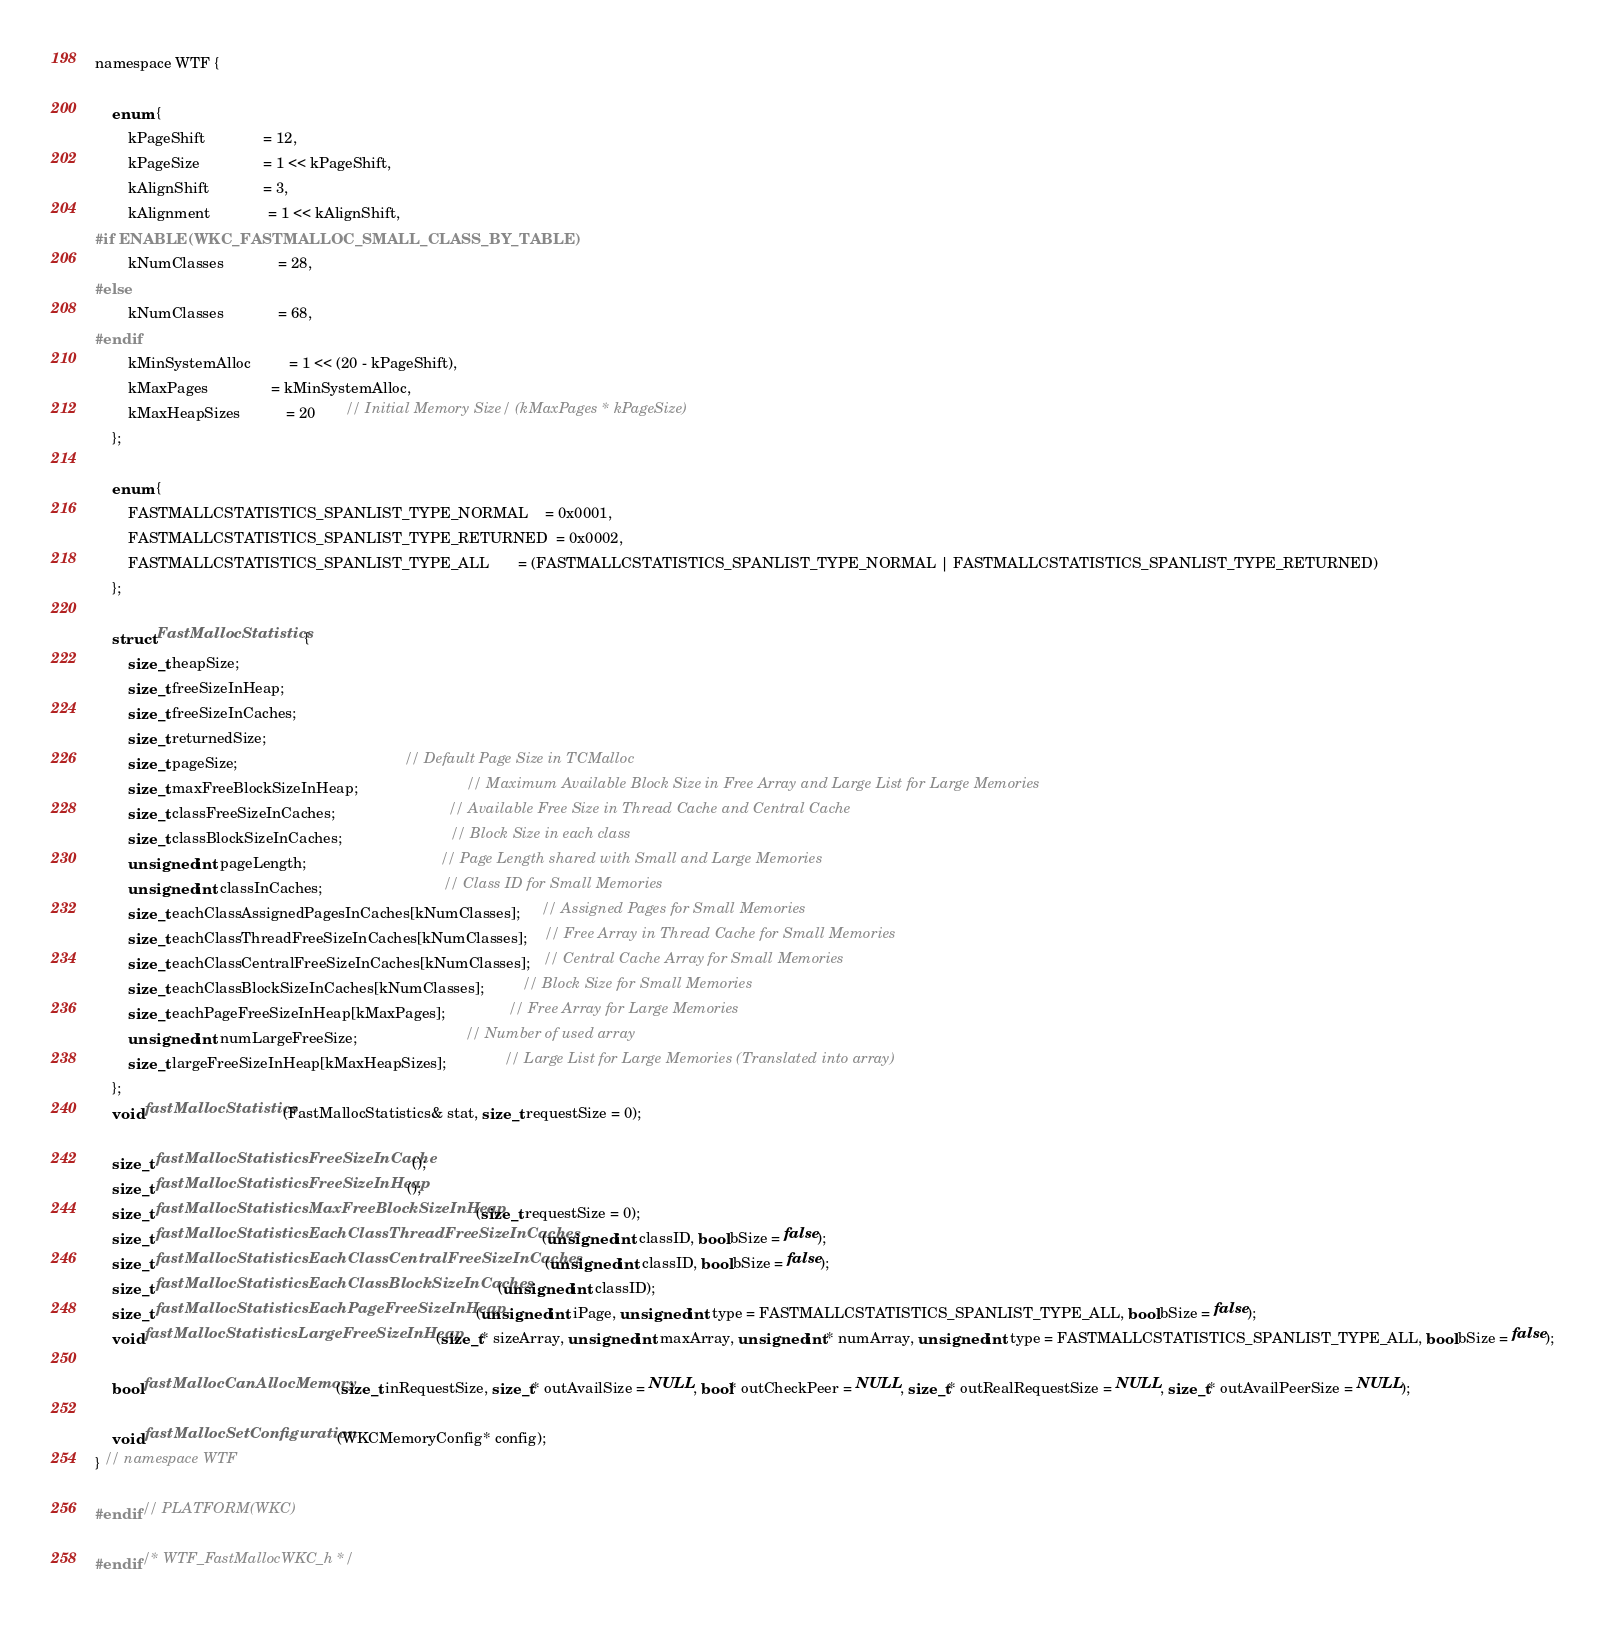Convert code to text. <code><loc_0><loc_0><loc_500><loc_500><_C_>
namespace WTF {

    enum {
        kPageShift              = 12,
        kPageSize               = 1 << kPageShift,
        kAlignShift             = 3,
        kAlignment              = 1 << kAlignShift,
#if ENABLE(WKC_FASTMALLOC_SMALL_CLASS_BY_TABLE)
        kNumClasses             = 28,
#else
        kNumClasses             = 68,
#endif
        kMinSystemAlloc         = 1 << (20 - kPageShift),
        kMaxPages               = kMinSystemAlloc,
        kMaxHeapSizes           = 20       // Initial Memory Size/ (kMaxPages * kPageSize)
    };

    enum {
        FASTMALLCSTATISTICS_SPANLIST_TYPE_NORMAL    = 0x0001,
        FASTMALLCSTATISTICS_SPANLIST_TYPE_RETURNED  = 0x0002,
        FASTMALLCSTATISTICS_SPANLIST_TYPE_ALL       = (FASTMALLCSTATISTICS_SPANLIST_TYPE_NORMAL | FASTMALLCSTATISTICS_SPANLIST_TYPE_RETURNED)
    };

    struct FastMallocStatistics {
        size_t heapSize;
        size_t freeSizeInHeap;
        size_t freeSizeInCaches;
        size_t returnedSize;
        size_t pageSize;                                        // Default Page Size in TCMalloc
        size_t maxFreeBlockSizeInHeap;                          // Maximum Available Block Size in Free Array and Large List for Large Memories
        size_t classFreeSizeInCaches;                           // Available Free Size in Thread Cache and Central Cache
        size_t classBlockSizeInCaches;                          // Block Size in each class
        unsigned int pageLength;                                // Page Length shared with Small and Large Memories
        unsigned int classInCaches;                             // Class ID for Small Memories
        size_t eachClassAssignedPagesInCaches[kNumClasses];     // Assigned Pages for Small Memories
        size_t eachClassThreadFreeSizeInCaches[kNumClasses];    // Free Array in Thread Cache for Small Memories
        size_t eachClassCentralFreeSizeInCaches[kNumClasses];   // Central Cache Array for Small Memories
        size_t eachClassBlockSizeInCaches[kNumClasses];         // Block Size for Small Memories
        size_t eachPageFreeSizeInHeap[kMaxPages];               // Free Array for Large Memories
        unsigned int numLargeFreeSize;                          // Number of used array
        size_t largeFreeSizeInHeap[kMaxHeapSizes];              // Large List for Large Memories (Translated into array)
    };
    void fastMallocStatistics(FastMallocStatistics& stat, size_t requestSize = 0);

    size_t fastMallocStatisticsFreeSizeInCache();
    size_t fastMallocStatisticsFreeSizeInHeap();
    size_t fastMallocStatisticsMaxFreeBlockSizeInHeap(size_t requestSize = 0);
    size_t fastMallocStatisticsEachClassThreadFreeSizeInCaches(unsigned int classID, bool bSize = false);
    size_t fastMallocStatisticsEachClassCentralFreeSizeInCaches(unsigned int classID, bool bSize = false);
    size_t fastMallocStatisticsEachClassBlockSizeInCaches(unsigned int classID);
    size_t fastMallocStatisticsEachPageFreeSizeInHeap(unsigned int iPage, unsigned int type = FASTMALLCSTATISTICS_SPANLIST_TYPE_ALL, bool bSize = false);
    void fastMallocStatisticsLargeFreeSizeInHeap(size_t* sizeArray, unsigned int maxArray, unsigned int* numArray, unsigned int type = FASTMALLCSTATISTICS_SPANLIST_TYPE_ALL, bool bSize = false);

    bool fastMallocCanAllocMemory(size_t inRequestSize, size_t* outAvailSize = NULL, bool* outCheckPeer = NULL, size_t* outRealRequestSize = NULL, size_t* outAvailPeerSize = NULL);

    void fastMallocSetConfiguration(WKCMemoryConfig* config);
} // namespace WTF

#endif // PLATFORM(WKC)

#endif /* WTF_FastMallocWKC_h */
</code> 